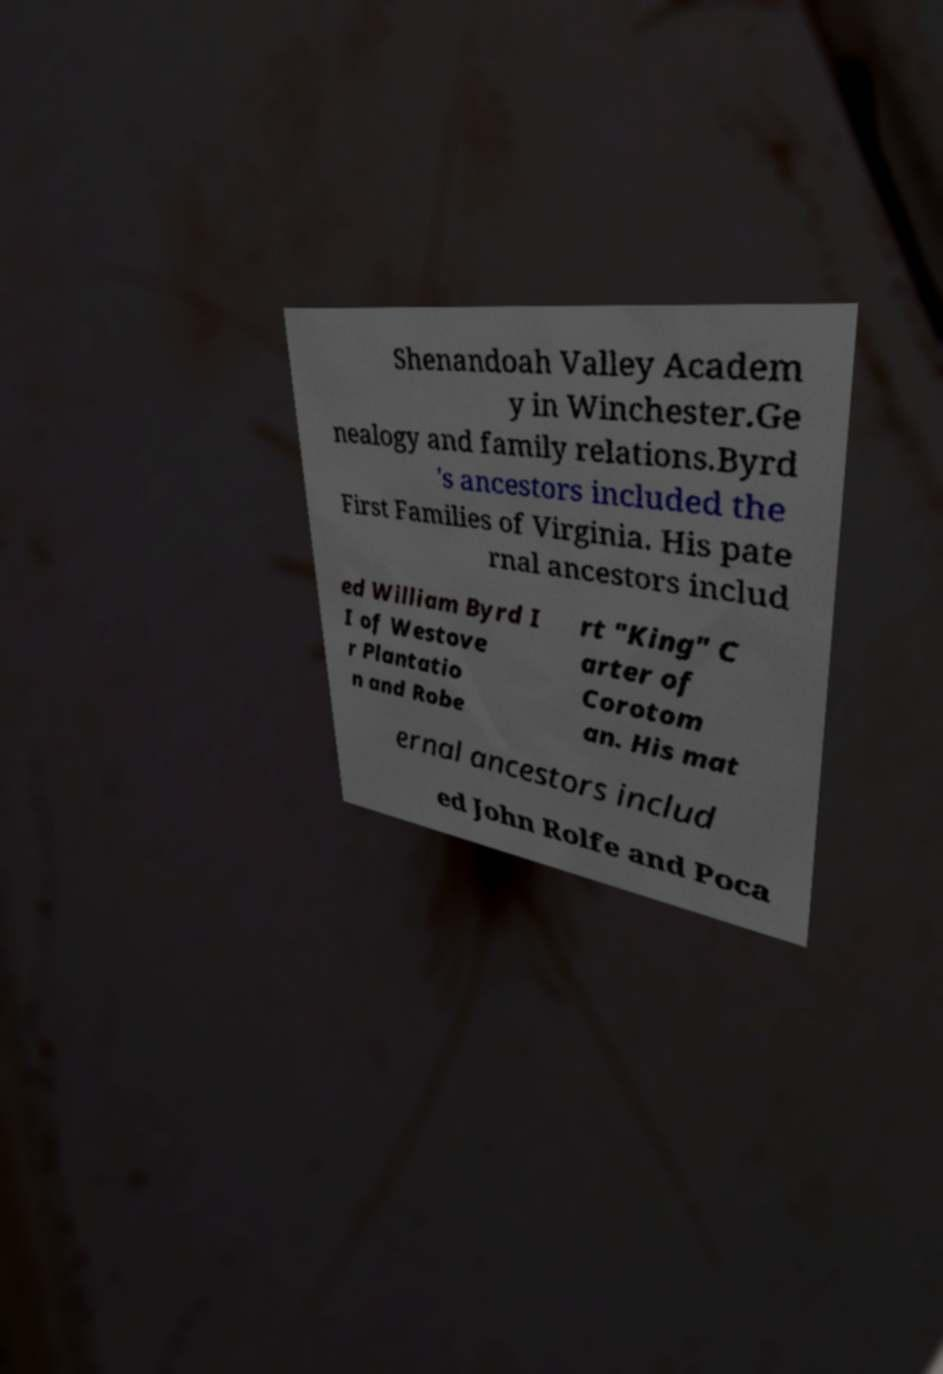Could you extract and type out the text from this image? Shenandoah Valley Academ y in Winchester.Ge nealogy and family relations.Byrd 's ancestors included the First Families of Virginia. His pate rnal ancestors includ ed William Byrd I I of Westove r Plantatio n and Robe rt "King" C arter of Corotom an. His mat ernal ancestors includ ed John Rolfe and Poca 